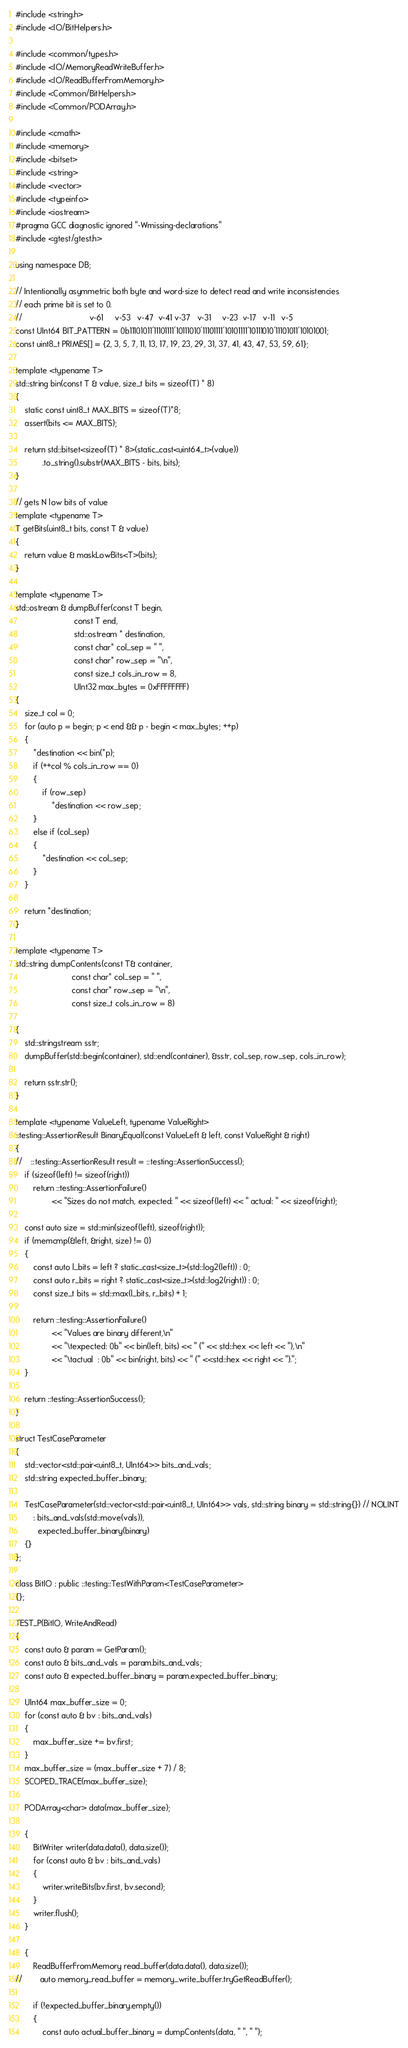Convert code to text. <code><loc_0><loc_0><loc_500><loc_500><_C++_>#include <string.h>
#include <IO/BitHelpers.h>

#include <common/types.h>
#include <IO/MemoryReadWriteBuffer.h>
#include <IO/ReadBufferFromMemory.h>
#include <Common/BitHelpers.h>
#include <Common/PODArray.h>

#include <cmath>
#include <memory>
#include <bitset>
#include <string>
#include <vector>
#include <typeinfo>
#include <iostream>
#pragma GCC diagnostic ignored "-Wmissing-declarations"
#include <gtest/gtest.h>

using namespace DB;

// Intentionally asymmetric both byte and word-size to detect read and write inconsistencies
// each prime bit is set to 0.
//                              v-61     v-53   v-47  v-41 v-37   v-31     v-23  v-17   v-11   v-5
const UInt64 BIT_PATTERN = 0b11101011'11101111'10111010'11101111'10101111'10111010'11101011'10101001;
const uint8_t PRIMES[] = {2, 3, 5, 7, 11, 13, 17, 19, 23, 29, 31, 37, 41, 43, 47, 53, 59, 61};

template <typename T>
std::string bin(const T & value, size_t bits = sizeof(T) * 8)
{
    static const uint8_t MAX_BITS = sizeof(T)*8;
    assert(bits <= MAX_BITS);

    return std::bitset<sizeof(T) * 8>(static_cast<uint64_t>(value))
            .to_string().substr(MAX_BITS - bits, bits);
}

// gets N low bits of value
template <typename T>
T getBits(uint8_t bits, const T & value)
{
    return value & maskLowBits<T>(bits);
}

template <typename T>
std::ostream & dumpBuffer(const T begin,
                          const T end,
                          std::ostream * destination,
                          const char* col_sep = " ",
                          const char* row_sep = "\n",
                          const size_t cols_in_row = 8,
                          UInt32 max_bytes = 0xFFFFFFFF)
{
    size_t col = 0;
    for (auto p = begin; p < end && p - begin < max_bytes; ++p)
    {
        *destination << bin(*p);
        if (++col % cols_in_row == 0)
        {
            if (row_sep)
                *destination << row_sep;
        }
        else if (col_sep)
        {
            *destination << col_sep;
        }
    }

    return *destination;
}

template <typename T>
std::string dumpContents(const T& container,
                         const char* col_sep = " ",
                         const char* row_sep = "\n",
                         const size_t cols_in_row = 8)

{
    std::stringstream sstr;
    dumpBuffer(std::begin(container), std::end(container), &sstr, col_sep, row_sep, cols_in_row);

    return sstr.str();
}

template <typename ValueLeft, typename ValueRight>
::testing::AssertionResult BinaryEqual(const ValueLeft & left, const ValueRight & right)
{
//    ::testing::AssertionResult result = ::testing::AssertionSuccess();
    if (sizeof(left) != sizeof(right))
        return ::testing::AssertionFailure()
                << "Sizes do not match, expected: " << sizeof(left) << " actual: " << sizeof(right);

    const auto size = std::min(sizeof(left), sizeof(right));
    if (memcmp(&left, &right, size) != 0)
    {
        const auto l_bits = left ? static_cast<size_t>(std::log2(left)) : 0;
        const auto r_bits = right ? static_cast<size_t>(std::log2(right)) : 0;
        const size_t bits = std::max(l_bits, r_bits) + 1;

        return ::testing::AssertionFailure()
                << "Values are binary different,\n"
                << "\texpected: 0b" << bin(left, bits) << " (" << std::hex << left << "),\n"
                << "\tactual  : 0b" << bin(right, bits) << " (" <<std::hex << right << ").";
    }

    return ::testing::AssertionSuccess();
}

struct TestCaseParameter
{
    std::vector<std::pair<uint8_t, UInt64>> bits_and_vals;
    std::string expected_buffer_binary;

    TestCaseParameter(std::vector<std::pair<uint8_t, UInt64>> vals, std::string binary = std::string{}) // NOLINT
        : bits_and_vals(std::move(vals)),
          expected_buffer_binary(binary)
    {}
};

class BitIO : public ::testing::TestWithParam<TestCaseParameter>
{};

TEST_P(BitIO, WriteAndRead)
{
    const auto & param = GetParam();
    const auto & bits_and_vals = param.bits_and_vals;
    const auto & expected_buffer_binary = param.expected_buffer_binary;

    UInt64 max_buffer_size = 0;
    for (const auto & bv : bits_and_vals)
    {
        max_buffer_size += bv.first;
    }
    max_buffer_size = (max_buffer_size + 7) / 8;
    SCOPED_TRACE(max_buffer_size);

    PODArray<char> data(max_buffer_size);

    {
        BitWriter writer(data.data(), data.size());
        for (const auto & bv : bits_and_vals)
        {
            writer.writeBits(bv.first, bv.second);
        }
        writer.flush();
    }

    {
        ReadBufferFromMemory read_buffer(data.data(), data.size());
//        auto memory_read_buffer = memory_write_buffer.tryGetReadBuffer();

        if (!expected_buffer_binary.empty())
        {
            const auto actual_buffer_binary = dumpContents(data, " ", " ");</code> 